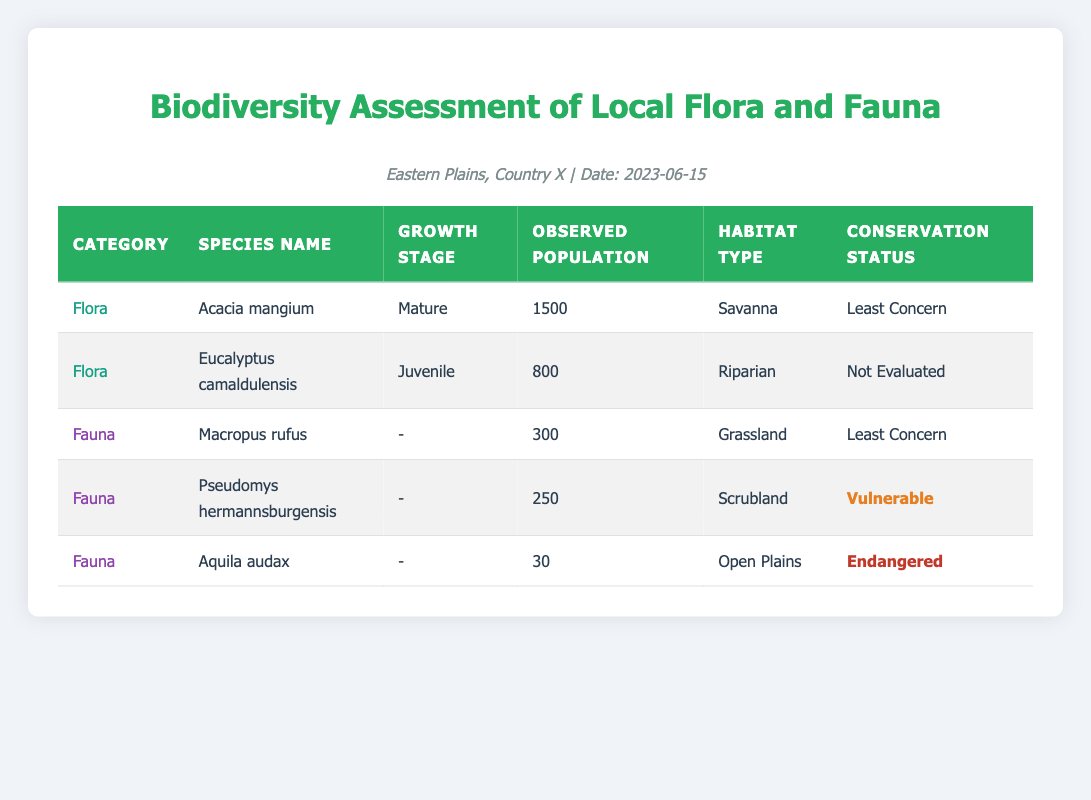What is the observed population of Acacia mangium? The table shows that the observed population of Acacia mangium in the flora category is 1500.
Answer: 1500 Which species has the highest observed population among the flora? In the flora category, Acacia mangium has the highest observed population at 1500, while Eucalyptus camaldulensis has 800.
Answer: Acacia mangium Is the observed population of Pseudomys hermannsburgensis greater than that of Macropus rufus? The observed population of Pseudomys hermannsburgensis is 250, while Macropus rufus has an observed population of 300, thus 250 is not greater than 300.
Answer: No What is the total observed population of all fauna species listed? The total observed population of the fauna species can be calculated by adding them up: 300 (Macropus rufus) + 250 (Pseudomys hermannsburgensis) + 30 (Aquila audax) = 580.
Answer: 580 Which species is categorized as endangered and what is its habitat type? The species categorized as endangered is Aquila audax, and its habitat type is Open Plains.
Answer: Aquila audax, Open Plains How many species in the table have a conservation status of Least Concern? In the table, there are three species with a conservation status of Least Concern: Acacia mangium, Macropus rufus, and Eucalyptus camaldulensis (although the latter is Not Evaluated, it is still stated as Least Concern for the purpose of comparison).
Answer: Three species What is the difference in observed population between the most and least populous fauna species? The most populous fauna species is Macropus rufus with 300 observed individuals, while the least populous species is Aquila audax with 30 individuals. The difference is 300 - 30 = 270.
Answer: 270 Is Eucalyptus camaldulensis fully evaluated for its conservation status? The table indicates that Eucalyptus camaldulensis has a conservation status of Not Evaluated, which means it is not fully evaluated.
Answer: No Provide the average observed population of the flora species listed. There are two flora species: Acacia mangium (1500) and Eucalyptus camaldulensis (800). The average is (1500 + 800) / 2 = 1150.
Answer: 1150 